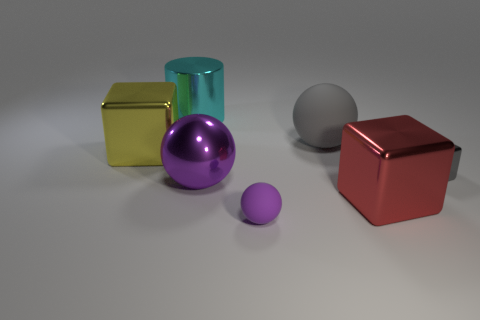Subtract all cyan cylinders. How many purple spheres are left? 2 Subtract all gray spheres. How many spheres are left? 2 Add 1 big metallic things. How many objects exist? 8 Subtract all green spheres. Subtract all purple cylinders. How many spheres are left? 3 Add 2 tiny things. How many tiny things exist? 4 Subtract 1 cyan cylinders. How many objects are left? 6 Subtract all blocks. How many objects are left? 4 Subtract all tiny green matte cubes. Subtract all large purple shiny balls. How many objects are left? 6 Add 6 large gray objects. How many large gray objects are left? 7 